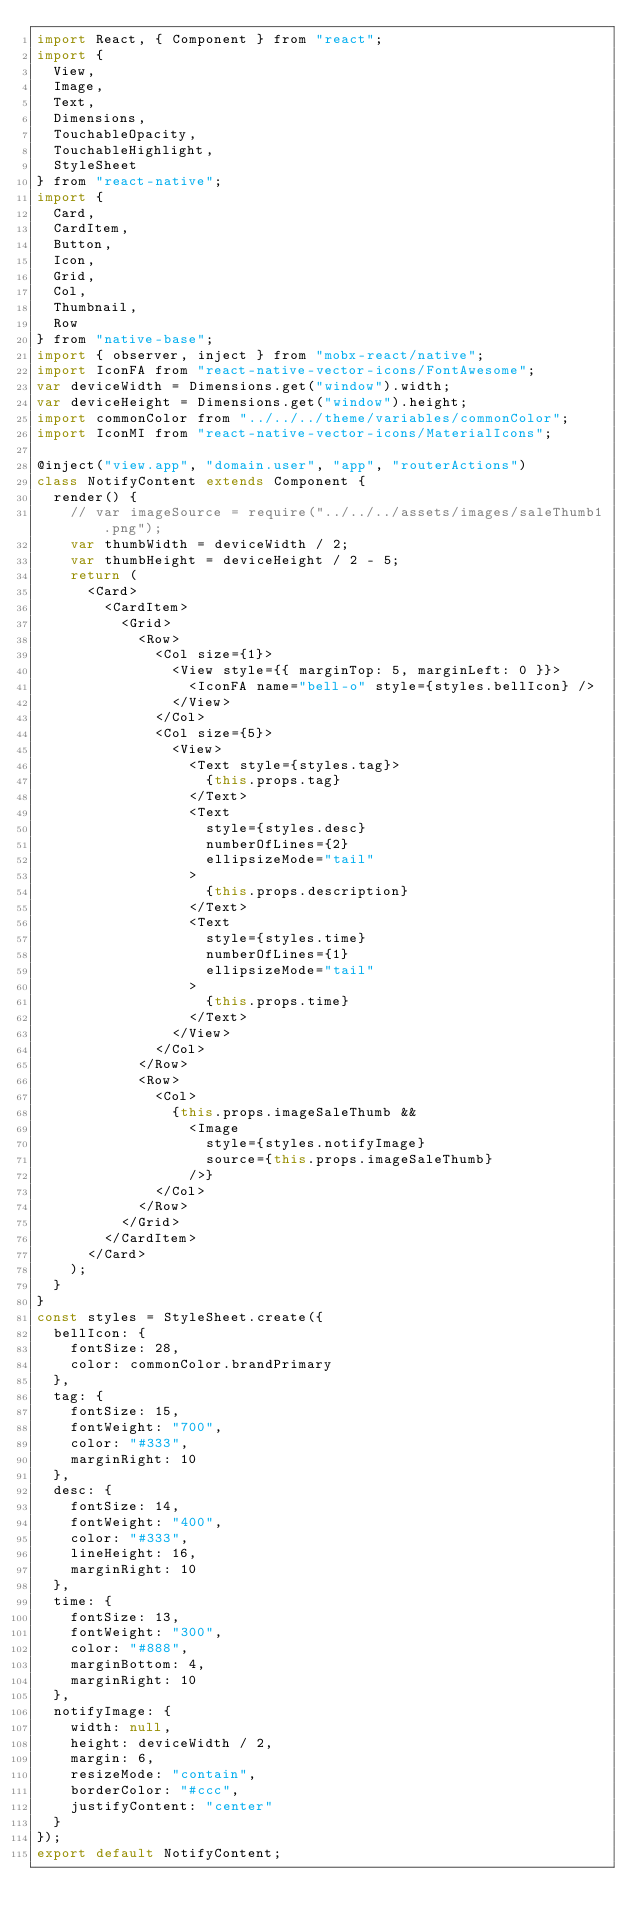<code> <loc_0><loc_0><loc_500><loc_500><_JavaScript_>import React, { Component } from "react";
import {
  View,
  Image,
  Text,
  Dimensions,
  TouchableOpacity,
  TouchableHighlight,
  StyleSheet
} from "react-native";
import {
  Card,
  CardItem,
  Button,
  Icon,
  Grid,
  Col,
  Thumbnail,
  Row
} from "native-base";
import { observer, inject } from "mobx-react/native";
import IconFA from "react-native-vector-icons/FontAwesome";
var deviceWidth = Dimensions.get("window").width;
var deviceHeight = Dimensions.get("window").height;
import commonColor from "../../../theme/variables/commonColor";
import IconMI from "react-native-vector-icons/MaterialIcons";

@inject("view.app", "domain.user", "app", "routerActions")
class NotifyContent extends Component {
  render() {
    // var imageSource = require("../../../assets/images/saleThumb1.png");
    var thumbWidth = deviceWidth / 2;
    var thumbHeight = deviceHeight / 2 - 5;
    return (
      <Card>
        <CardItem>
          <Grid>
            <Row>
              <Col size={1}>
                <View style={{ marginTop: 5, marginLeft: 0 }}>
                  <IconFA name="bell-o" style={styles.bellIcon} />
                </View>
              </Col>
              <Col size={5}>
                <View>
                  <Text style={styles.tag}>
                    {this.props.tag}
                  </Text>
                  <Text
                    style={styles.desc}
                    numberOfLines={2}
                    ellipsizeMode="tail"
                  >
                    {this.props.description}
                  </Text>
                  <Text
                    style={styles.time}
                    numberOfLines={1}
                    ellipsizeMode="tail"
                  >
                    {this.props.time}
                  </Text>
                </View>
              </Col>
            </Row>
            <Row>
              <Col>
                {this.props.imageSaleThumb &&
                  <Image
                    style={styles.notifyImage}
                    source={this.props.imageSaleThumb}
                  />}
              </Col>
            </Row>
          </Grid>
        </CardItem>
      </Card>
    );
  }
}
const styles = StyleSheet.create({
  bellIcon: {
    fontSize: 28,
    color: commonColor.brandPrimary
  },
  tag: {
    fontSize: 15,
    fontWeight: "700",
    color: "#333",
    marginRight: 10
  },
  desc: {
    fontSize: 14,
    fontWeight: "400",
    color: "#333",
    lineHeight: 16,
    marginRight: 10
  },
  time: {
    fontSize: 13,
    fontWeight: "300",
    color: "#888",
    marginBottom: 4,
    marginRight: 10
  },
  notifyImage: {
    width: null,
    height: deviceWidth / 2,
    margin: 6,
    resizeMode: "contain",
    borderColor: "#ccc",
    justifyContent: "center"
  }
});
export default NotifyContent;
</code> 